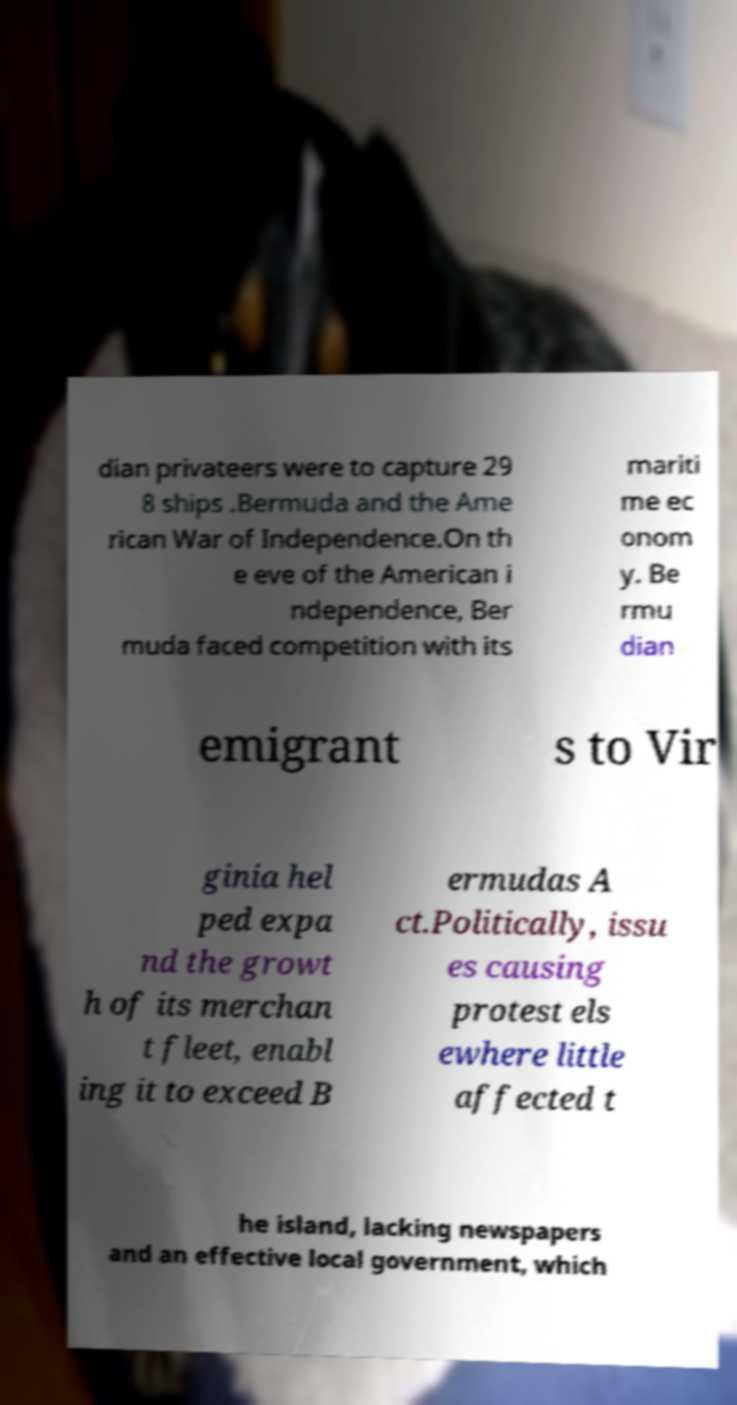Can you accurately transcribe the text from the provided image for me? dian privateers were to capture 29 8 ships .Bermuda and the Ame rican War of Independence.On th e eve of the American i ndependence, Ber muda faced competition with its mariti me ec onom y. Be rmu dian emigrant s to Vir ginia hel ped expa nd the growt h of its merchan t fleet, enabl ing it to exceed B ermudas A ct.Politically, issu es causing protest els ewhere little affected t he island, lacking newspapers and an effective local government, which 